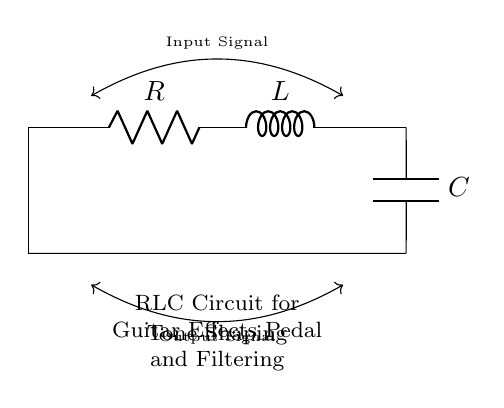What components are in this circuit? The circuit contains a resistor, an inductor, and a capacitor. These are standard components that interact to shape and filter signals.
Answer: Resistor, Inductor, Capacitor What is the primary function of this RLC circuit? The primary function of this RLC circuit is tone shaping and filtering, which is crucial in guitar effects pedals to modify the sound characteristics.
Answer: Tone shaping and filtering What type of signals does this RLC circuit work with? The circuit processes input and output signals, typically audio signals in the context of guitar effects.
Answer: Audio signals What happens when the frequency of the input signal is increased? Increasing the frequency changes the impedance of the circuit components (especially the capacitor and inductor), altering the tone produced by the circuit.
Answer: Alters tone How does the inductor affect the circuit's performance in tone shaping? The inductor's reactance increases with frequency, which means it opposes changes in current. This affects how the circuit responds to different frequencies, adding inductive filtering characteristics.
Answer: Opposes current changes What is the role of the capacitor in this RLC circuit? The capacitor stores and releases energy, affecting the timing and shape of the output signal, which is essential for filtering specific frequency ranges.
Answer: Stores and releases energy Are the components connected in series or parallel? The components are connected in series, which affects how the total impedance and voltage are calculated across the circuit.
Answer: Series 